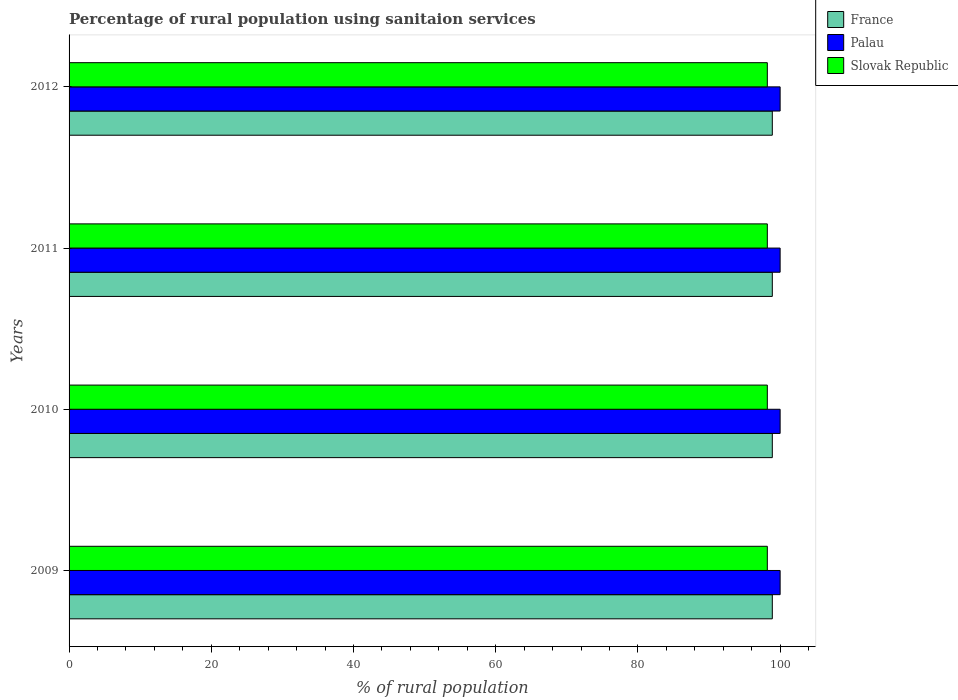How many groups of bars are there?
Your response must be concise. 4. Are the number of bars per tick equal to the number of legend labels?
Give a very brief answer. Yes. How many bars are there on the 4th tick from the bottom?
Provide a succinct answer. 3. What is the label of the 1st group of bars from the top?
Provide a short and direct response. 2012. What is the percentage of rural population using sanitaion services in France in 2012?
Offer a very short reply. 98.9. Across all years, what is the maximum percentage of rural population using sanitaion services in France?
Your answer should be compact. 98.9. Across all years, what is the minimum percentage of rural population using sanitaion services in Slovak Republic?
Ensure brevity in your answer.  98.2. In which year was the percentage of rural population using sanitaion services in France minimum?
Give a very brief answer. 2009. What is the total percentage of rural population using sanitaion services in Slovak Republic in the graph?
Ensure brevity in your answer.  392.8. What is the difference between the percentage of rural population using sanitaion services in Slovak Republic in 2011 and the percentage of rural population using sanitaion services in France in 2012?
Give a very brief answer. -0.7. What is the average percentage of rural population using sanitaion services in France per year?
Your answer should be compact. 98.9. In the year 2009, what is the difference between the percentage of rural population using sanitaion services in Slovak Republic and percentage of rural population using sanitaion services in France?
Provide a succinct answer. -0.7. In how many years, is the percentage of rural population using sanitaion services in Slovak Republic greater than 28 %?
Your answer should be very brief. 4. What is the ratio of the percentage of rural population using sanitaion services in France in 2009 to that in 2012?
Provide a short and direct response. 1. Is the percentage of rural population using sanitaion services in Palau in 2009 less than that in 2010?
Your answer should be compact. No. Is the difference between the percentage of rural population using sanitaion services in Slovak Republic in 2009 and 2012 greater than the difference between the percentage of rural population using sanitaion services in France in 2009 and 2012?
Your response must be concise. No. What is the difference between the highest and the second highest percentage of rural population using sanitaion services in Palau?
Keep it short and to the point. 0. In how many years, is the percentage of rural population using sanitaion services in Slovak Republic greater than the average percentage of rural population using sanitaion services in Slovak Republic taken over all years?
Ensure brevity in your answer.  0. Is the sum of the percentage of rural population using sanitaion services in Slovak Republic in 2009 and 2012 greater than the maximum percentage of rural population using sanitaion services in Palau across all years?
Make the answer very short. Yes. What does the 3rd bar from the top in 2012 represents?
Offer a terse response. France. What does the 2nd bar from the bottom in 2011 represents?
Offer a very short reply. Palau. How many bars are there?
Your answer should be very brief. 12. Are the values on the major ticks of X-axis written in scientific E-notation?
Give a very brief answer. No. Does the graph contain grids?
Provide a succinct answer. No. Where does the legend appear in the graph?
Give a very brief answer. Top right. How are the legend labels stacked?
Provide a short and direct response. Vertical. What is the title of the graph?
Offer a terse response. Percentage of rural population using sanitaion services. Does "Costa Rica" appear as one of the legend labels in the graph?
Your response must be concise. No. What is the label or title of the X-axis?
Your response must be concise. % of rural population. What is the % of rural population of France in 2009?
Your answer should be compact. 98.9. What is the % of rural population of Palau in 2009?
Your answer should be very brief. 100. What is the % of rural population of Slovak Republic in 2009?
Make the answer very short. 98.2. What is the % of rural population in France in 2010?
Ensure brevity in your answer.  98.9. What is the % of rural population in Palau in 2010?
Offer a very short reply. 100. What is the % of rural population in Slovak Republic in 2010?
Your answer should be very brief. 98.2. What is the % of rural population of France in 2011?
Your response must be concise. 98.9. What is the % of rural population of Slovak Republic in 2011?
Ensure brevity in your answer.  98.2. What is the % of rural population of France in 2012?
Offer a terse response. 98.9. What is the % of rural population of Palau in 2012?
Ensure brevity in your answer.  100. What is the % of rural population in Slovak Republic in 2012?
Keep it short and to the point. 98.2. Across all years, what is the maximum % of rural population of France?
Keep it short and to the point. 98.9. Across all years, what is the maximum % of rural population of Slovak Republic?
Offer a very short reply. 98.2. Across all years, what is the minimum % of rural population of France?
Ensure brevity in your answer.  98.9. Across all years, what is the minimum % of rural population in Slovak Republic?
Give a very brief answer. 98.2. What is the total % of rural population in France in the graph?
Your answer should be very brief. 395.6. What is the total % of rural population of Palau in the graph?
Make the answer very short. 400. What is the total % of rural population of Slovak Republic in the graph?
Give a very brief answer. 392.8. What is the difference between the % of rural population in France in 2009 and that in 2010?
Provide a succinct answer. 0. What is the difference between the % of rural population of Slovak Republic in 2009 and that in 2010?
Ensure brevity in your answer.  0. What is the difference between the % of rural population of Palau in 2009 and that in 2012?
Your answer should be compact. 0. What is the difference between the % of rural population in Slovak Republic in 2009 and that in 2012?
Your answer should be compact. 0. What is the difference between the % of rural population in Palau in 2010 and that in 2011?
Give a very brief answer. 0. What is the difference between the % of rural population in Slovak Republic in 2010 and that in 2011?
Ensure brevity in your answer.  0. What is the difference between the % of rural population in France in 2009 and the % of rural population in Slovak Republic in 2011?
Your answer should be compact. 0.7. What is the difference between the % of rural population in France in 2009 and the % of rural population in Slovak Republic in 2012?
Offer a terse response. 0.7. What is the difference between the % of rural population of Palau in 2009 and the % of rural population of Slovak Republic in 2012?
Ensure brevity in your answer.  1.8. What is the difference between the % of rural population of France in 2011 and the % of rural population of Palau in 2012?
Provide a short and direct response. -1.1. What is the average % of rural population in France per year?
Give a very brief answer. 98.9. What is the average % of rural population in Palau per year?
Keep it short and to the point. 100. What is the average % of rural population of Slovak Republic per year?
Make the answer very short. 98.2. In the year 2009, what is the difference between the % of rural population of France and % of rural population of Palau?
Offer a very short reply. -1.1. In the year 2010, what is the difference between the % of rural population in Palau and % of rural population in Slovak Republic?
Give a very brief answer. 1.8. In the year 2011, what is the difference between the % of rural population of France and % of rural population of Palau?
Offer a terse response. -1.1. In the year 2011, what is the difference between the % of rural population in France and % of rural population in Slovak Republic?
Your response must be concise. 0.7. In the year 2011, what is the difference between the % of rural population of Palau and % of rural population of Slovak Republic?
Ensure brevity in your answer.  1.8. In the year 2012, what is the difference between the % of rural population of France and % of rural population of Slovak Republic?
Make the answer very short. 0.7. In the year 2012, what is the difference between the % of rural population in Palau and % of rural population in Slovak Republic?
Your response must be concise. 1.8. What is the ratio of the % of rural population in Slovak Republic in 2009 to that in 2010?
Your answer should be very brief. 1. What is the ratio of the % of rural population of Slovak Republic in 2009 to that in 2011?
Provide a short and direct response. 1. What is the ratio of the % of rural population of France in 2009 to that in 2012?
Your response must be concise. 1. What is the ratio of the % of rural population of Palau in 2009 to that in 2012?
Offer a terse response. 1. What is the ratio of the % of rural population of Slovak Republic in 2009 to that in 2012?
Provide a short and direct response. 1. What is the ratio of the % of rural population in Palau in 2010 to that in 2011?
Offer a very short reply. 1. What is the ratio of the % of rural population in Slovak Republic in 2010 to that in 2012?
Ensure brevity in your answer.  1. What is the ratio of the % of rural population of Palau in 2011 to that in 2012?
Offer a terse response. 1. What is the ratio of the % of rural population in Slovak Republic in 2011 to that in 2012?
Offer a terse response. 1. What is the difference between the highest and the second highest % of rural population in France?
Offer a terse response. 0. What is the difference between the highest and the second highest % of rural population of Slovak Republic?
Keep it short and to the point. 0. What is the difference between the highest and the lowest % of rural population in France?
Your answer should be compact. 0. What is the difference between the highest and the lowest % of rural population in Slovak Republic?
Provide a short and direct response. 0. 